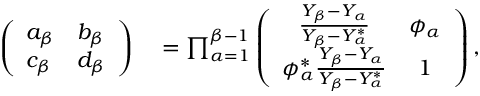<formula> <loc_0><loc_0><loc_500><loc_500>\begin{array} { r l } { \left ( \begin{array} { l l } { a _ { \beta } } & { b _ { \beta } } \\ { c _ { \beta } } & { d _ { \beta } } \end{array} \right ) } & = \prod _ { \alpha = 1 } ^ { \beta - 1 } \left ( \begin{array} { c c } { \frac { Y _ { \beta } - Y _ { \alpha } } { Y _ { \beta } - Y _ { \alpha } ^ { * } } } & { \phi _ { \alpha } } \\ { \phi _ { \alpha } ^ { * } \frac { Y _ { \beta } - Y _ { \alpha } } { Y _ { \beta } - Y _ { \alpha } ^ { * } } } & { 1 } \end{array} \right ) , } \end{array}</formula> 